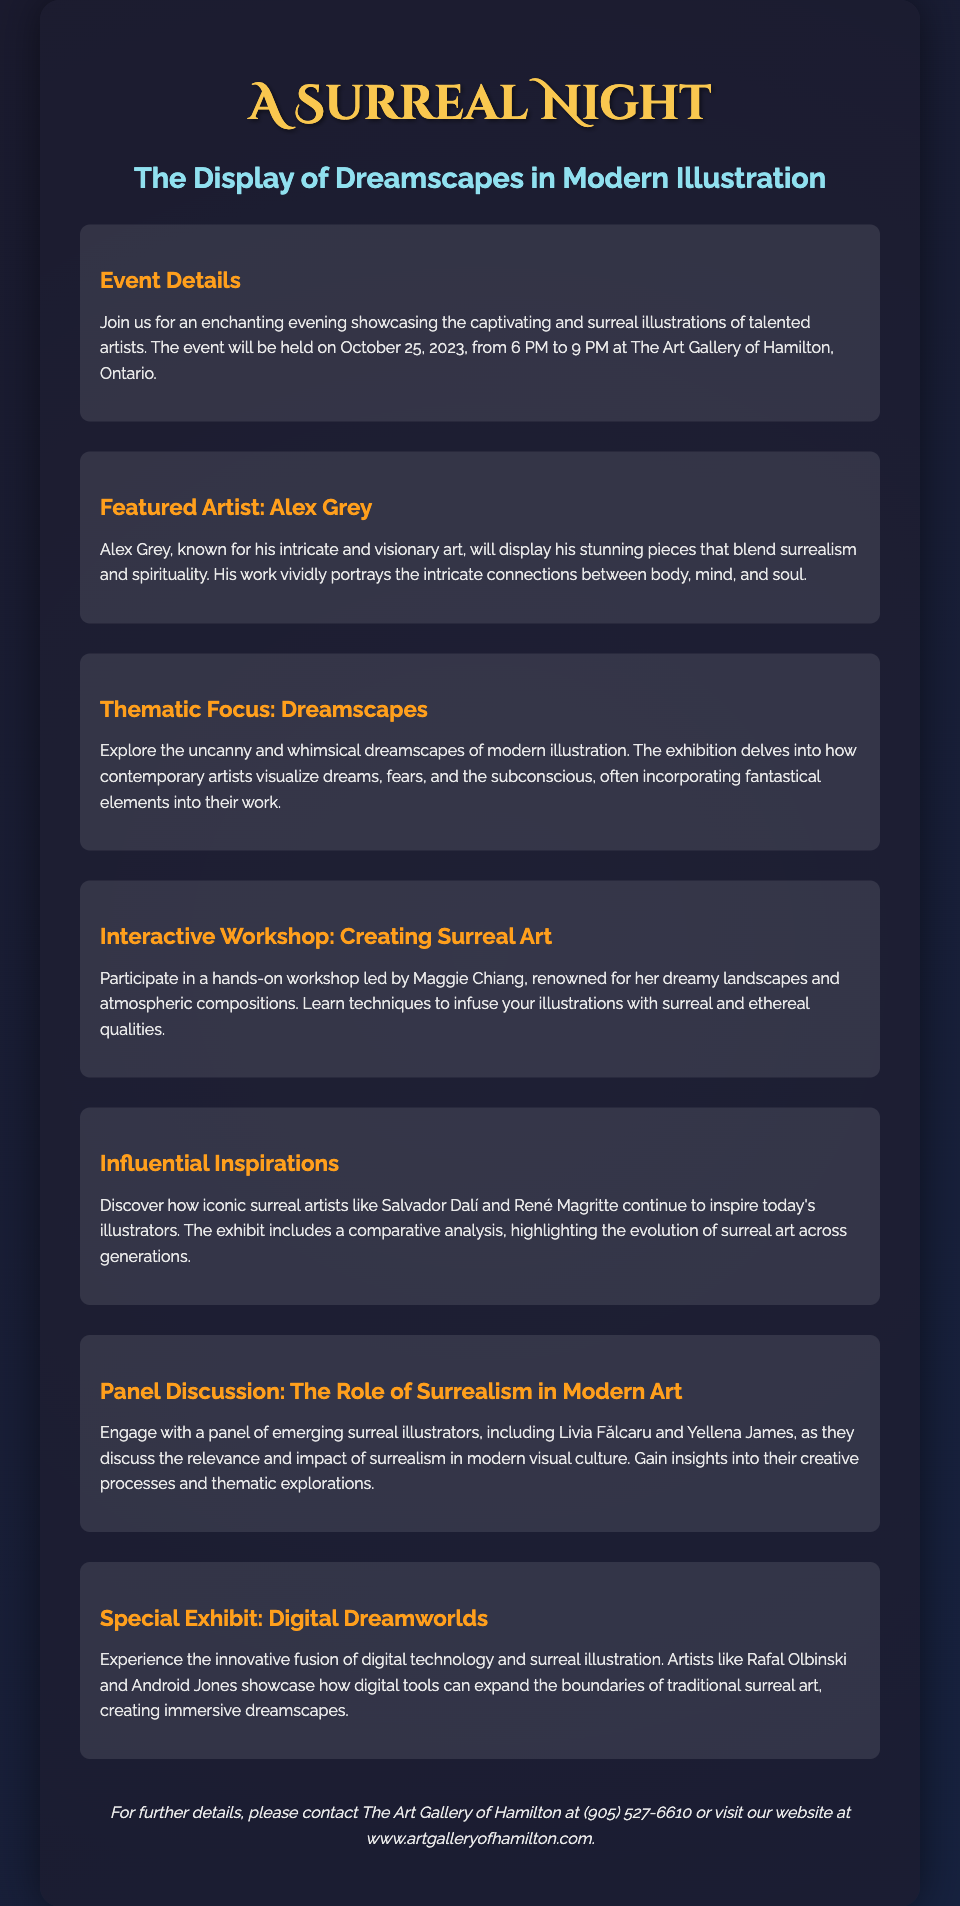What is the date of the event? The date of the event is explicitly mentioned in the document as October 25, 2023.
Answer: October 25, 2023 Who is the featured artist? The document names Alex Grey as the featured artist.
Answer: Alex Grey What is the thematic focus of the exhibition? The thematic focus discussed in the document is how contemporary artists visualize dreams, fears, and the subconscious.
Answer: Dreamscapes Who is leading the interactive workshop? The document states that the interactive workshop is led by Maggie Chiang.
Answer: Maggie Chiang What is the duration of the event? The event is scheduled to take place from 6 PM to 9 PM, indicating a 3-hour duration.
Answer: 3 hours Which artists showcase digital dreamscapes? The document lists Rafal Olbinski and Android Jones as artists showcasing digital dreamscapes.
Answer: Rafal Olbinski and Android Jones What is one topic of the panel discussion? The panel discussion focuses on the relevance and impact of surrealism in modern visual culture.
Answer: The Role of Surrealism in Modern Art What is a key aspect highlighted in the Influential Inspirations section? The document mentions how iconic surreal artists like Salvador Dalí and René Magritte inspire today’s illustrators.
Answer: Inspiration from Salvador Dalí and René Magritte 